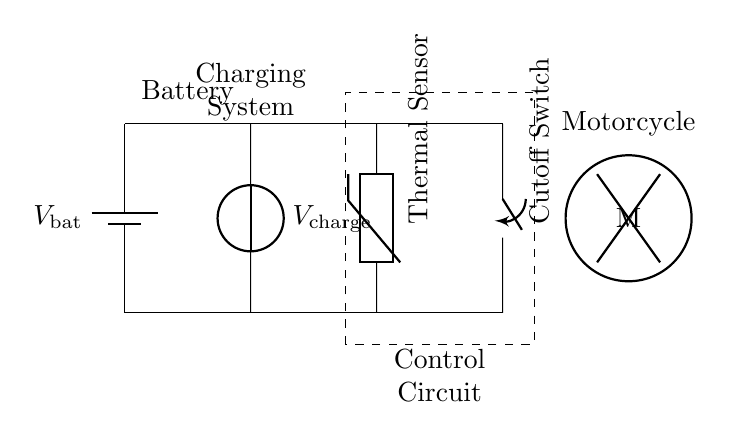What component is used to cut off the circuit in case of overheating? The circuit includes a Cutoff Switch, which is specifically used for disconnecting the charging circuit if the temperature exceeds a certain level, thus protecting the battery.
Answer: Cutoff Switch What does the thermal sensor measure? The Thermal Sensor monitors the temperature within the system, allowing the circuit to respond if overheating occurs, ensuring the protection of the battery and other components.
Answer: Temperature What is the main function of the control circuit? The Control Circuit manages all the components within the system, including interpreting signals from the thermal sensor and controlling the cutoff switch to disconnect the power when needed.
Answer: Management Which component generates the charging voltage? The circuit contains a Charging System that is responsible for supplying the necessary charging voltage to the battery, ensuring its proper functionality.
Answer: Charging System How many primary components are there in this protection circuit? There are four primary components in this protection circuit: the Battery, Charging System, Thermal Sensor, and Cutoff Switch, which collectively work to ensure safe operation.
Answer: Four What is the voltage source for the battery? The Battery is denoted with a voltage label indicating it is connected to a supplied voltage that is essential for powering the motorcycle's electrical systems.
Answer: V bat 